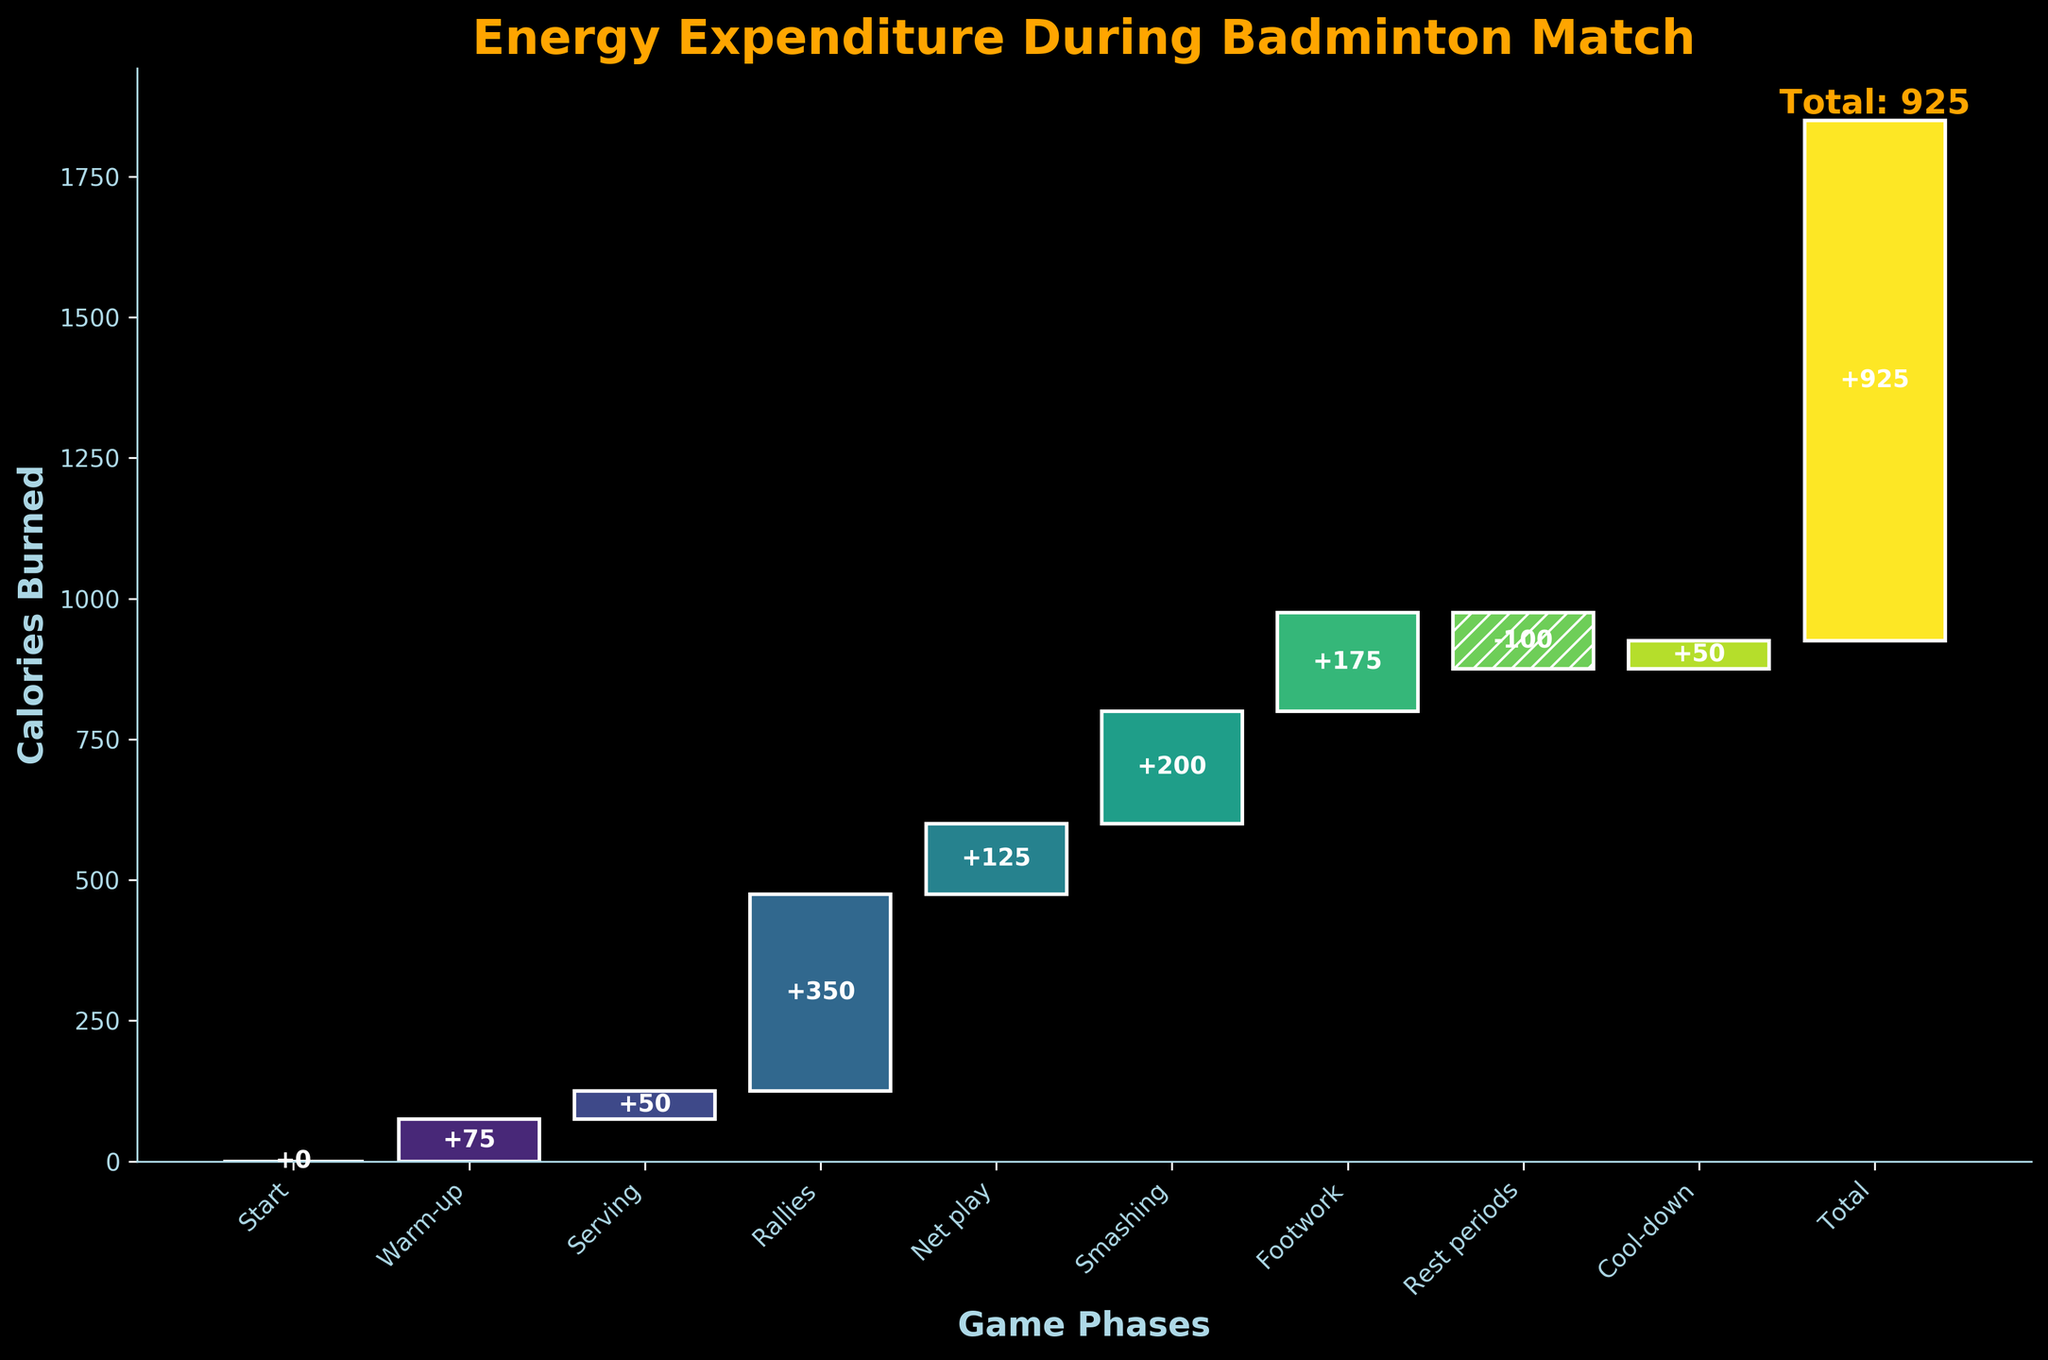What is the title of the figure? The title is usually prominently displayed at the top of the figure. In this chart, the title is "Energy Expenditure During Badminton Match"
Answer: Energy Expenditure During Badminton Match How many game phases are shown in the figure? Counting all distinct bars from the start to the total value, including Rest periods and Cool-down, there are 9 phases listed (excluding the Total)
Answer: 9 What are the calories burned during the 'Smashing' phase? Refer to the bar labeled 'Smashing' and observe the value displayed inside. It shows +200, indicating 200 calories burned.
Answer: 200 Which game phase resulted in negative calories burned? The phase with the hatched bar and a negative value indicates a loss of calories, which is the 'Rest periods' phase. The value for this phase is -100 calories.
Answer: Rest periods What's the difference in calories burned between 'Rallies' and 'Net play'? The value for 'Rallies' is 350 calories, and for 'Net play', it is 125 calories. The difference can be calculated as 350 - 125 = 225 calories.
Answer: 225 What is the cumulative calories burned by the end of 'Footwork'? Sum the values from 'Warm-up' to 'Footwork': 75 (Warm-up) + 50 (Serving) + 350 (Rallies) + 125 (Net play) + 200 (Smashing) + 175 (Footwork) = 975 calories.
Answer: 975 Which phase had the highest expenditure of calories? To determine this, compare the values of all the positive phases and identify the maximum. The 'Rallies' phase with 350 calories burned is the highest.
Answer: Rallies How does the 'Cool-down' phase compare to the 'Warm-up' phase in terms of calories burned? The 'Cool-down' phase burned 50 calories, whereas the 'Warm-up' phase burned 75 calories. 50 is less than 75.
Answer: Less than What is the total calories burned in the match? The figure shows the cumulative total highlighted at the end, next to the 'Total' label, which is +925 calories.
Answer: 925 What's the average calories burned per positive game phase? First, add up all positive values: 75 (Warm-up) + 50 (Serving) + 350 (Rallies) + 125 (Net play) + 200 (Smashing) + 175 (Footwork) + 50 (Cool-down) = 1025. Then, divide by the number of positive phases (7). 1025 / 7 = 146.43 calories.
Answer: 146.43 